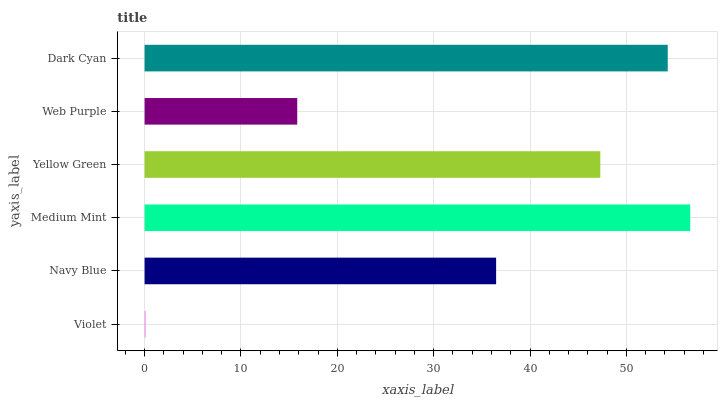Is Violet the minimum?
Answer yes or no. Yes. Is Medium Mint the maximum?
Answer yes or no. Yes. Is Navy Blue the minimum?
Answer yes or no. No. Is Navy Blue the maximum?
Answer yes or no. No. Is Navy Blue greater than Violet?
Answer yes or no. Yes. Is Violet less than Navy Blue?
Answer yes or no. Yes. Is Violet greater than Navy Blue?
Answer yes or no. No. Is Navy Blue less than Violet?
Answer yes or no. No. Is Yellow Green the high median?
Answer yes or no. Yes. Is Navy Blue the low median?
Answer yes or no. Yes. Is Web Purple the high median?
Answer yes or no. No. Is Dark Cyan the low median?
Answer yes or no. No. 